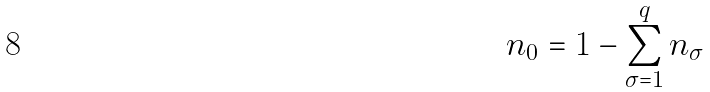<formula> <loc_0><loc_0><loc_500><loc_500>n _ { 0 } = 1 - \sum _ { \sigma = 1 } ^ { q } n _ { \sigma }</formula> 